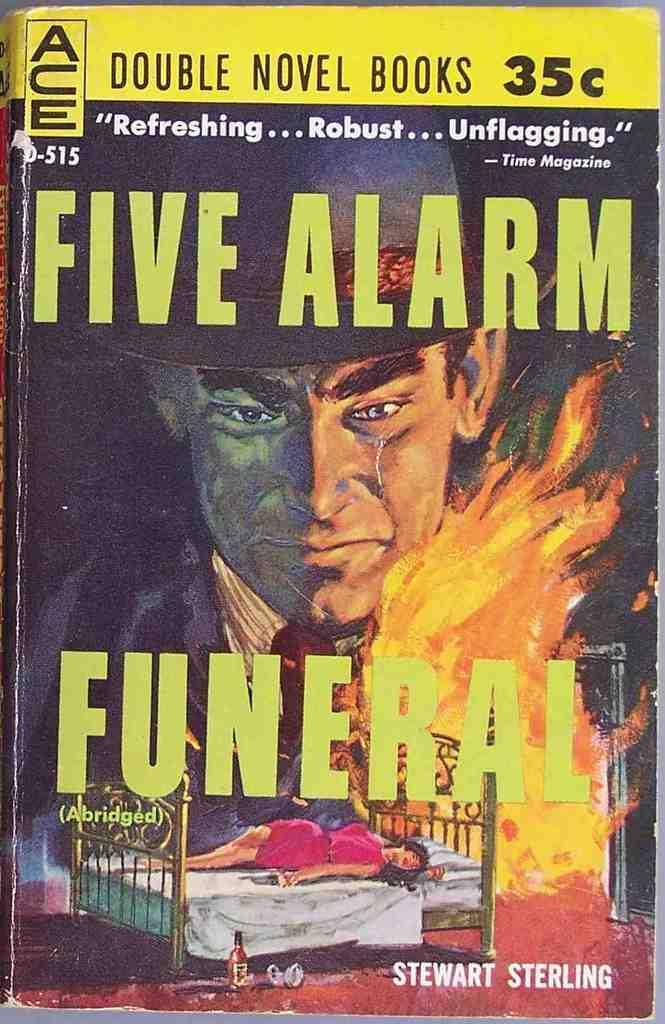<image>
Summarize the visual content of the image. A book by the name of Five Alarm Funeral 